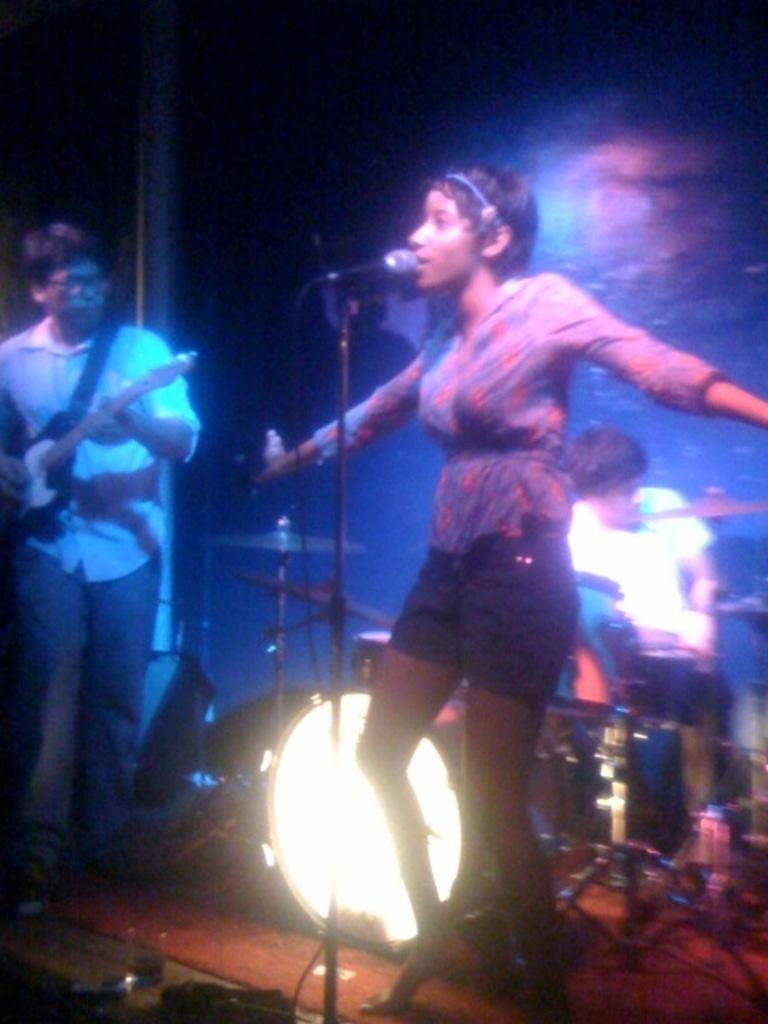Can you describe this image briefly? In the image there are three people one woman and two men. In the image there is a woman standing in front of a microphone and opened her mouth for singing behind the woman there is a man who is sitting and playing his musical instrument. On left side there is another man who is holding his guitar and playing it on bottom we can see a light. 